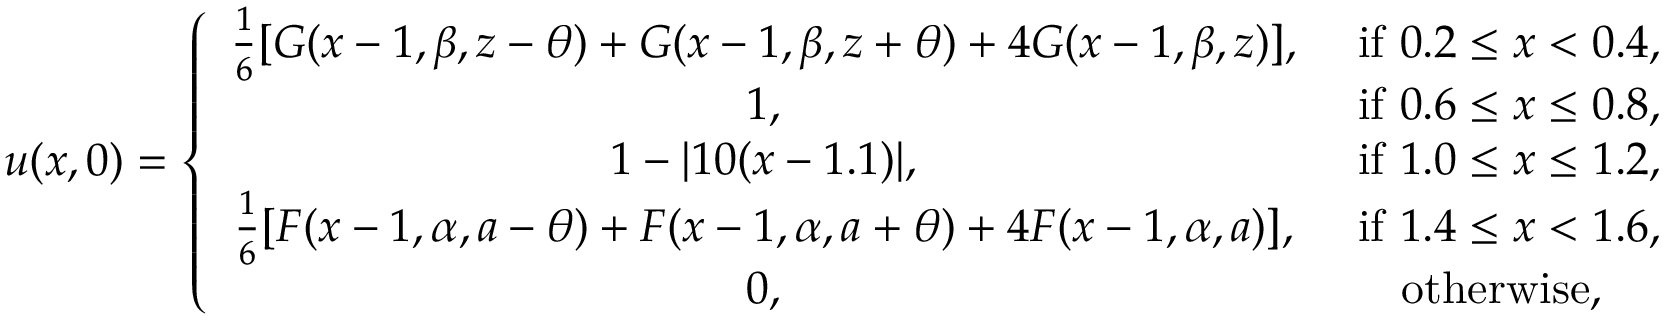Convert formula to latex. <formula><loc_0><loc_0><loc_500><loc_500>u ( x , 0 ) = \left \{ \begin{array} { c c } { \frac { 1 } { 6 } [ G ( x - 1 , \beta , z - \theta ) + G ( x - 1 , \beta , z + \theta ) + 4 G ( x - 1 , \beta , z ) ] , } & { i f 0 . 2 \leq x < 0 . 4 , } \\ { 1 , } & { i f 0 . 6 \leq x \leq 0 . 8 , } \\ { 1 - | 1 0 ( x - 1 . 1 ) | , } & { i f 1 . 0 \leq x \leq 1 . 2 , } \\ { \frac { 1 } { 6 } [ F ( x - 1 , \alpha , a - \theta ) + F ( x - 1 , \alpha , a + \theta ) + 4 F ( x - 1 , \alpha , a ) ] , } & { i f 1 . 4 \leq x < 1 . 6 , } \\ { 0 , } & { o t h e r w i s e , } \end{array}</formula> 